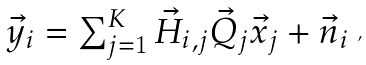<formula> <loc_0><loc_0><loc_500><loc_500>\begin{array} { l l l } \vec { y } _ { i } = \sum _ { j = 1 } ^ { K } \vec { H } _ { i , j } \vec { Q } _ { j } \vec { x } _ { j } + \vec { n } _ { i } \end{array} ,</formula> 